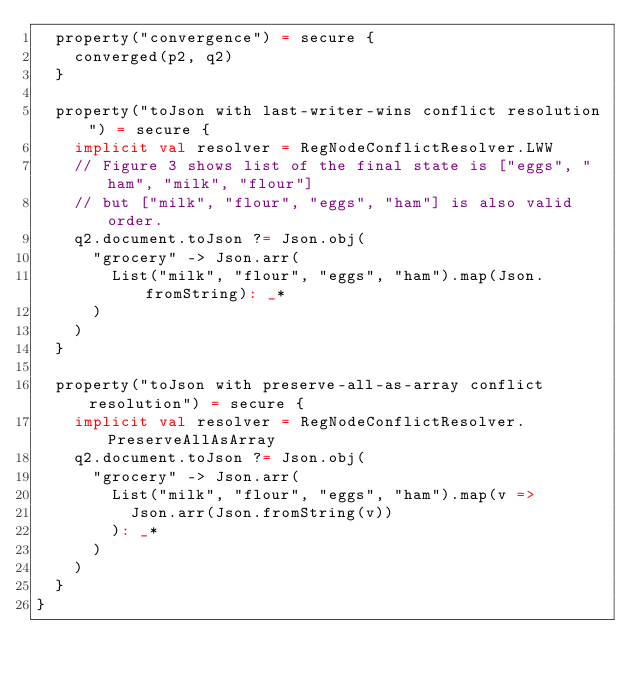<code> <loc_0><loc_0><loc_500><loc_500><_Scala_>  property("convergence") = secure {
    converged(p2, q2)
  }

  property("toJson with last-writer-wins conflict resolution") = secure {
    implicit val resolver = RegNodeConflictResolver.LWW
    // Figure 3 shows list of the final state is ["eggs", "ham", "milk", "flour"]
    // but ["milk", "flour", "eggs", "ham"] is also valid order.
    q2.document.toJson ?= Json.obj(
      "grocery" -> Json.arr(
        List("milk", "flour", "eggs", "ham").map(Json.fromString): _*
      )
    )
  }

  property("toJson with preserve-all-as-array conflict resolution") = secure {
    implicit val resolver = RegNodeConflictResolver.PreserveAllAsArray
    q2.document.toJson ?= Json.obj(
      "grocery" -> Json.arr(
        List("milk", "flour", "eggs", "ham").map(v =>
          Json.arr(Json.fromString(v))
        ): _*
      )
    )
  }
}
</code> 